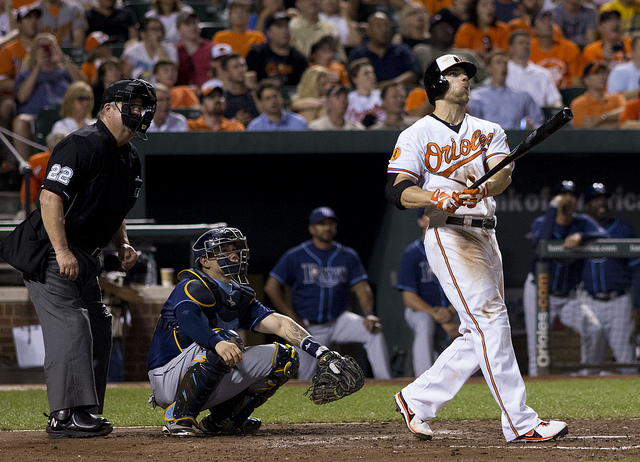Extract all visible text content from this image. Oriolez 22 